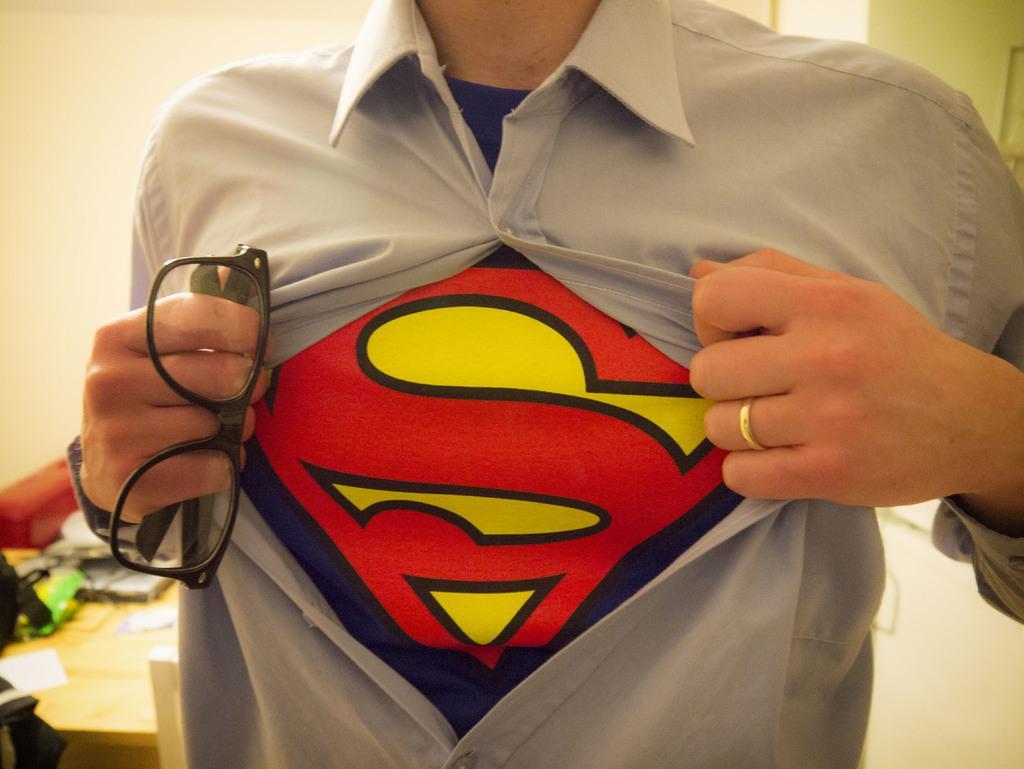Please provide a concise description of this image. In the center of the image we can see man holding spectacles. In the background we can see table and wall. 